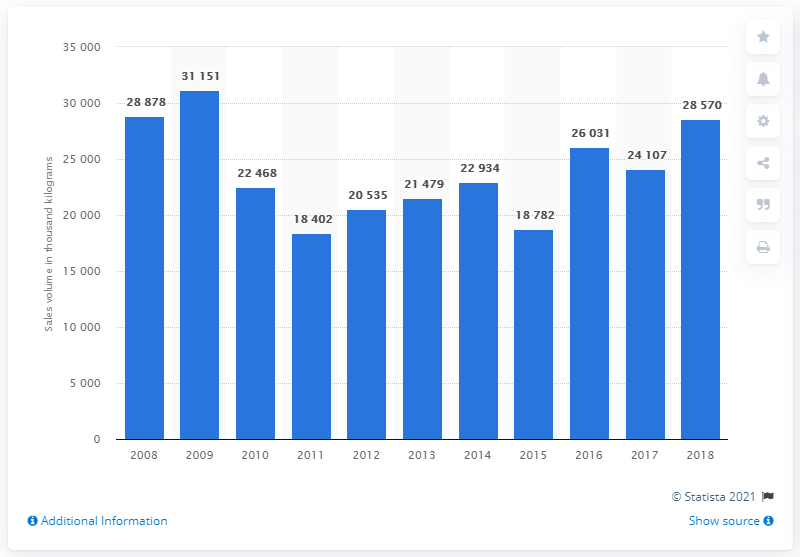Outline some significant characteristics in this image. In 2018, the sales volume of mixed fruit and nuts was 28,878 units. 